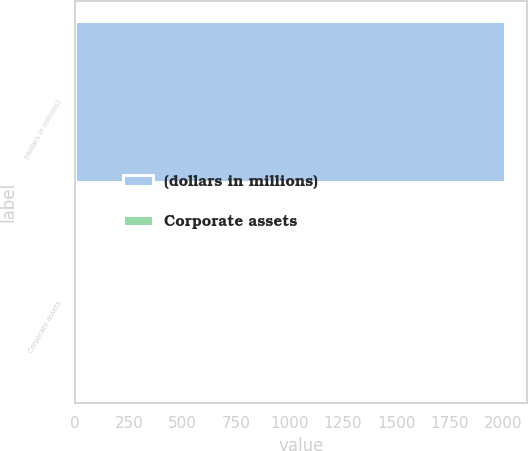Convert chart to OTSL. <chart><loc_0><loc_0><loc_500><loc_500><bar_chart><fcel>(dollars in millions)<fcel>Corporate assets<nl><fcel>2009<fcel>0.7<nl></chart> 